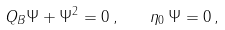Convert formula to latex. <formula><loc_0><loc_0><loc_500><loc_500>Q _ { B } \Psi + \Psi ^ { 2 } = 0 \, , \quad \eta _ { 0 } \, \Psi = 0 \, ,</formula> 